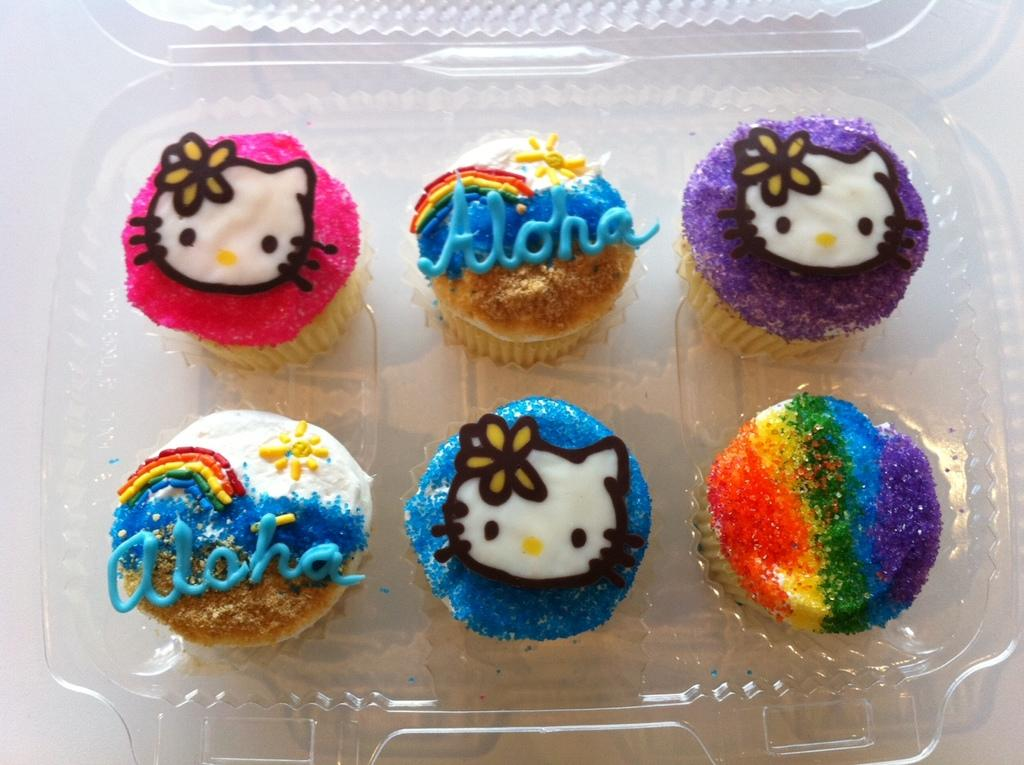What type of food is visible in the image? There are cupcakes in the image. How are the cupcakes packaged? The cupcakes are in a packet. Where is the packet of cupcakes located? The packet of cupcakes is placed on a table. What type of lead can be seen connecting the cupcakes in the image? There is no lead connecting the cupcakes in the image; they are in a packet. Are the cupcakes wearing gloves in the image? There are no gloves present in the image; it features cupcakes in a packet. 